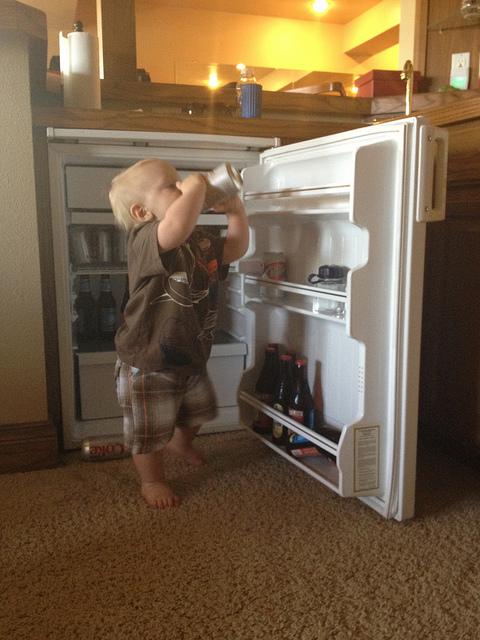Is the fridge open it?
Give a very brief answer. Yes. Is the child barefooted?
Give a very brief answer. Yes. What is the child doing?
Answer briefly. Drinking. 